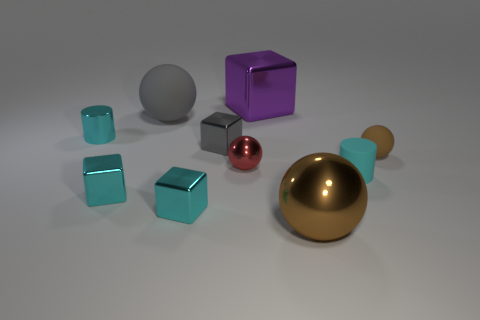There is a cylinder that is behind the tiny brown rubber ball; does it have the same color as the small matte cylinder?
Keep it short and to the point. Yes. What shape is the matte thing on the left side of the tiny rubber object that is in front of the small sphere that is on the left side of the small matte ball?
Make the answer very short. Sphere. What material is the cyan cylinder that is in front of the small matte object that is right of the cyan matte cylinder?
Your answer should be compact. Rubber. There is a big purple thing that is made of the same material as the gray block; what shape is it?
Your answer should be very brief. Cube. How many tiny spheres are to the left of the tiny brown rubber object?
Your answer should be compact. 1. Are any purple shiny cubes visible?
Provide a succinct answer. Yes. What is the color of the cylinder that is to the left of the large shiny object that is in front of the rubber ball on the left side of the tiny gray metal thing?
Your answer should be compact. Cyan. There is a small cyan cylinder that is on the left side of the big purple shiny object; is there a thing in front of it?
Offer a very short reply. Yes. There is a tiny matte object that is to the left of the small rubber ball; is its color the same as the tiny metallic block on the left side of the large gray ball?
Offer a terse response. Yes. What number of metal spheres have the same size as the gray matte sphere?
Provide a succinct answer. 1. 